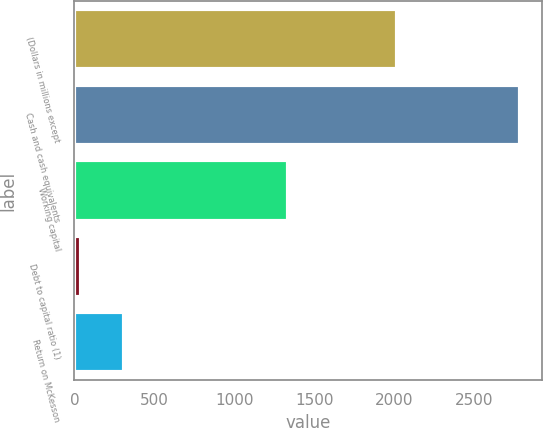<chart> <loc_0><loc_0><loc_500><loc_500><bar_chart><fcel>(Dollars in millions except<fcel>Cash and cash equivalents<fcel>Working capital<fcel>Debt to capital ratio (1)<fcel>Return on McKesson<nl><fcel>2017<fcel>2783<fcel>1336<fcel>39.2<fcel>313.58<nl></chart> 